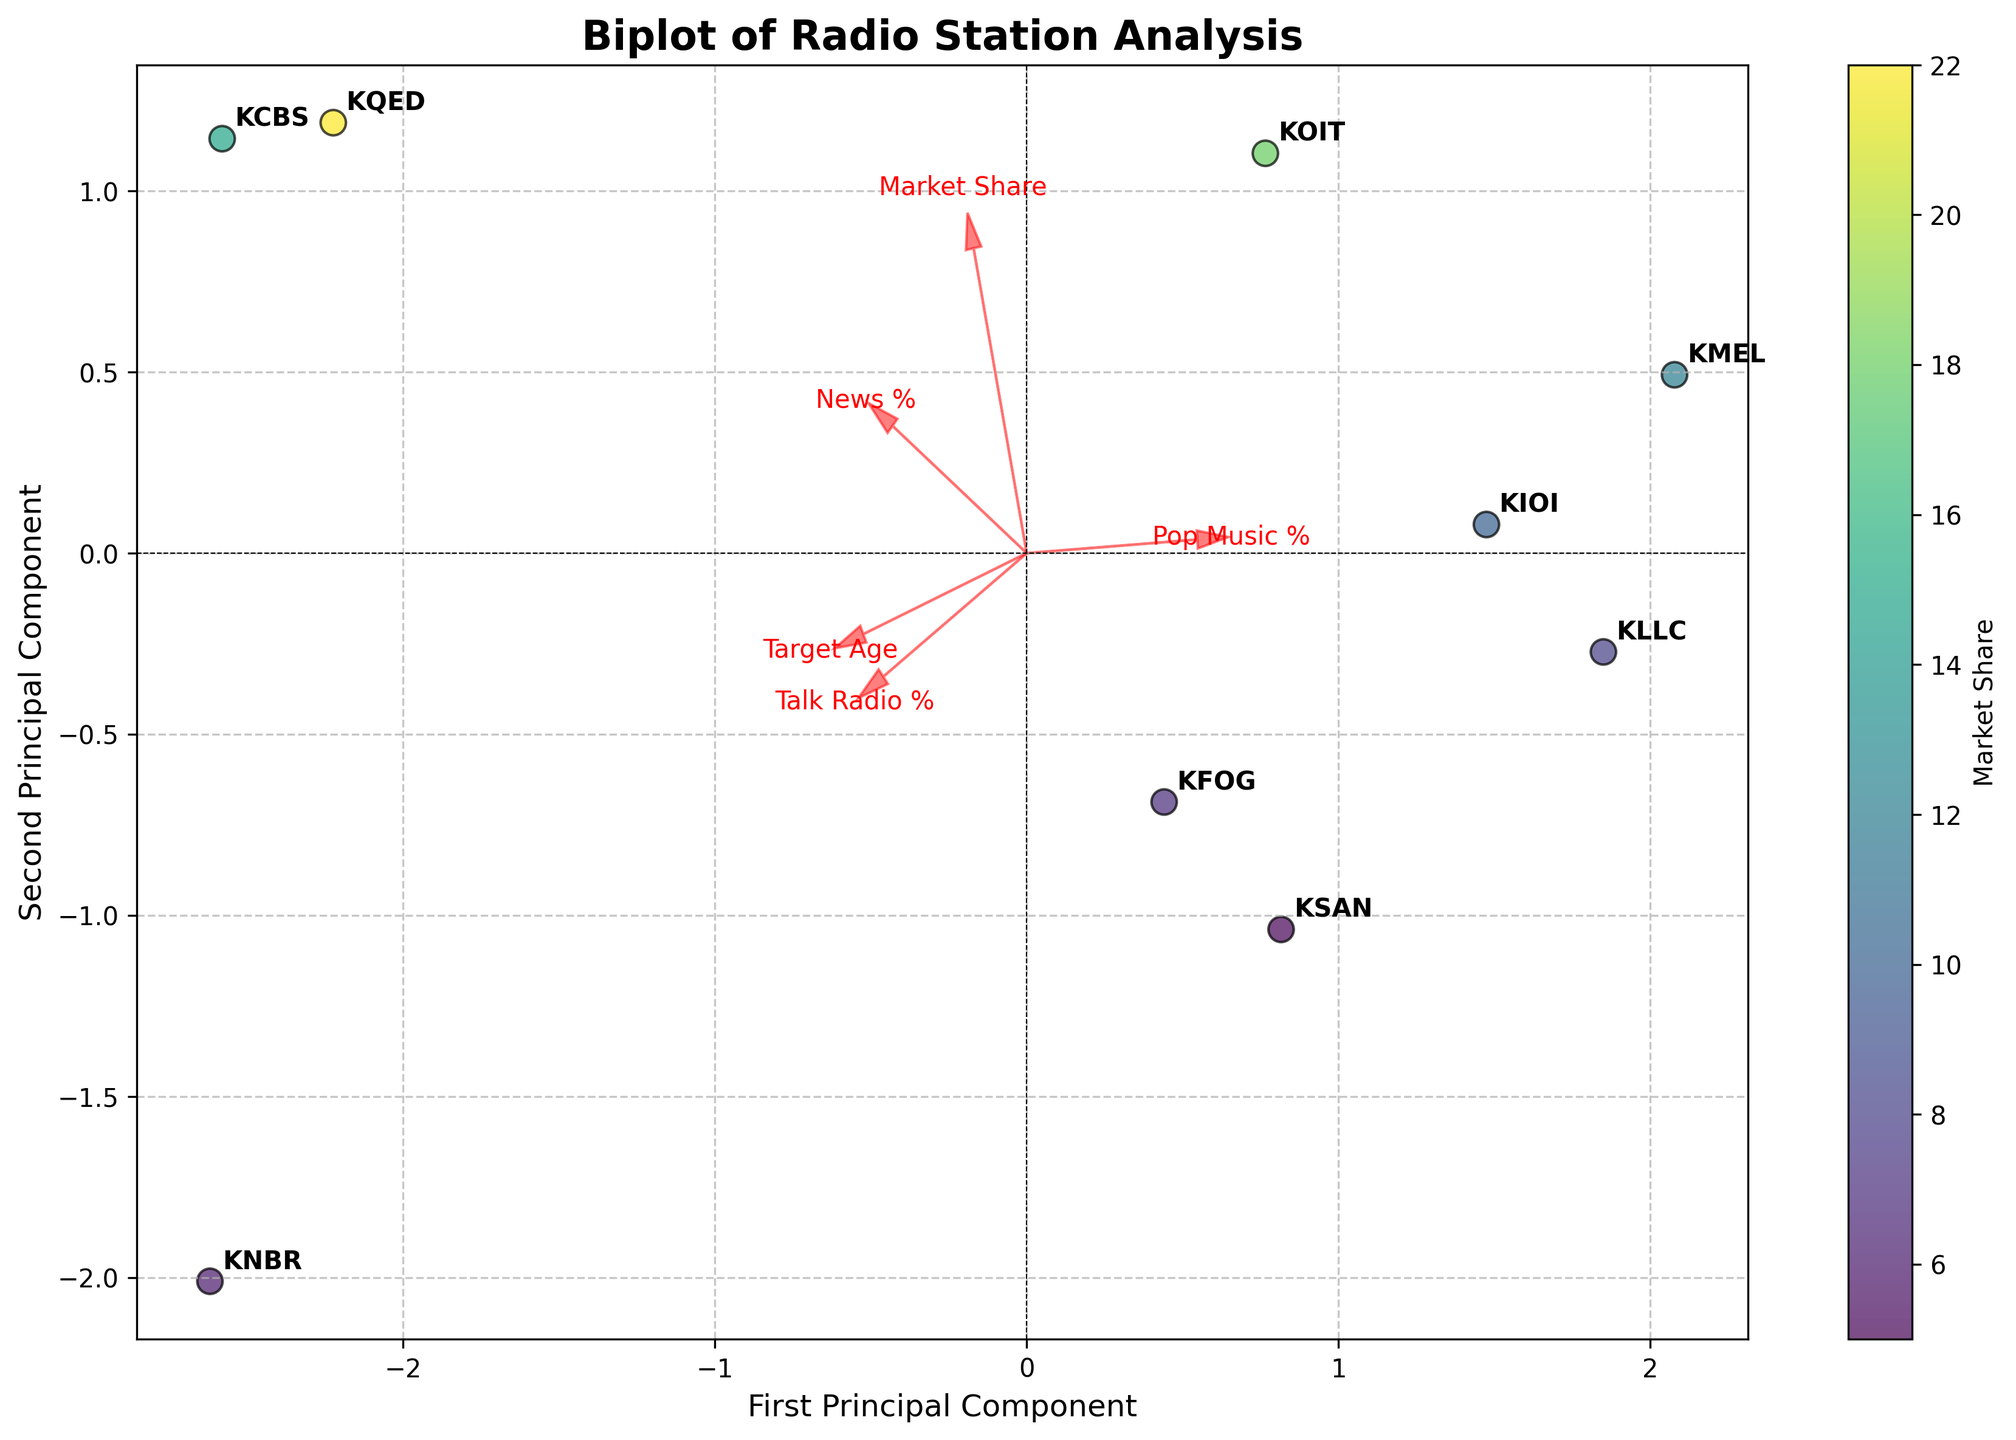How many radio stations are analyzed in the Biplot? By counting the number of data points (each represents a radio station) in the figure, we can see that there are 9 stations labeled on the Biplot.
Answer: 9 Which radio station has the highest market share according to the Biplot? The color bar indicates that 'KQED,' represented by the point with the darkest color, has the highest market share.
Answer: KQED Identify the two radio stations that target the youngest demographics. By looking at the positioning of the points and the feature vectors, 'KMEL' and 'KLLC' have the lowest values on the 'Target Age' vector, indicating they target the youngest audiences.
Answer: KMEL and KLLC Compare the amount of Pop Music percentage between 'KOIT' and 'KCBS'. Which one leads in Pop Music percentage? Looking at the position relative to the Pop Music % vector, 'KOIT' is positioned closer in the direction of increasing Pop Music %, making it higher in Pop Music percentage compared to 'KCBS.'
Answer: KOIT Which radio station is positioned furthest in the direction of the Talk Radio % vector and what does this indicate? 'KNBR' is the furthest in the direction of the Talk Radio % vector, indicating it has the highest Talk Radio percentage among the analyzed stations.
Answer: KNBR Explain why 'KCBS' and 'KQED' are relatively close on the Biplot. Both stations have high values in News % and Talk Radio %, which places them closer together in the reduced dimensional space defined by the principal components.
Answer: They have similarities in News % and Talk Radio % Which feature contributes most to the first principal component? The length of the arrows denotes feature contribution. The 'Market Share' vector is the longest along the first principal component, indicating it contributes the most.
Answer: Market Share Determine if 'KIOI' has a higher or lower News percentage compared to 'KSAN'. By evaluating their positions relative to the News % vector, 'KIOI' is positioned closer in the direction opposite to the News % vector, indicating it has a lower News percentage than 'KSAN'.
Answer: Lower What can be inferred about the relationship between the 'Pop Music %' and 'Talk Radio %' features? The arrows representing 'Pop Music %' and 'Talk Radio %' form nearly opposite directions, implying a strong negative correlation between these two features.
Answer: Strong negative correlation 